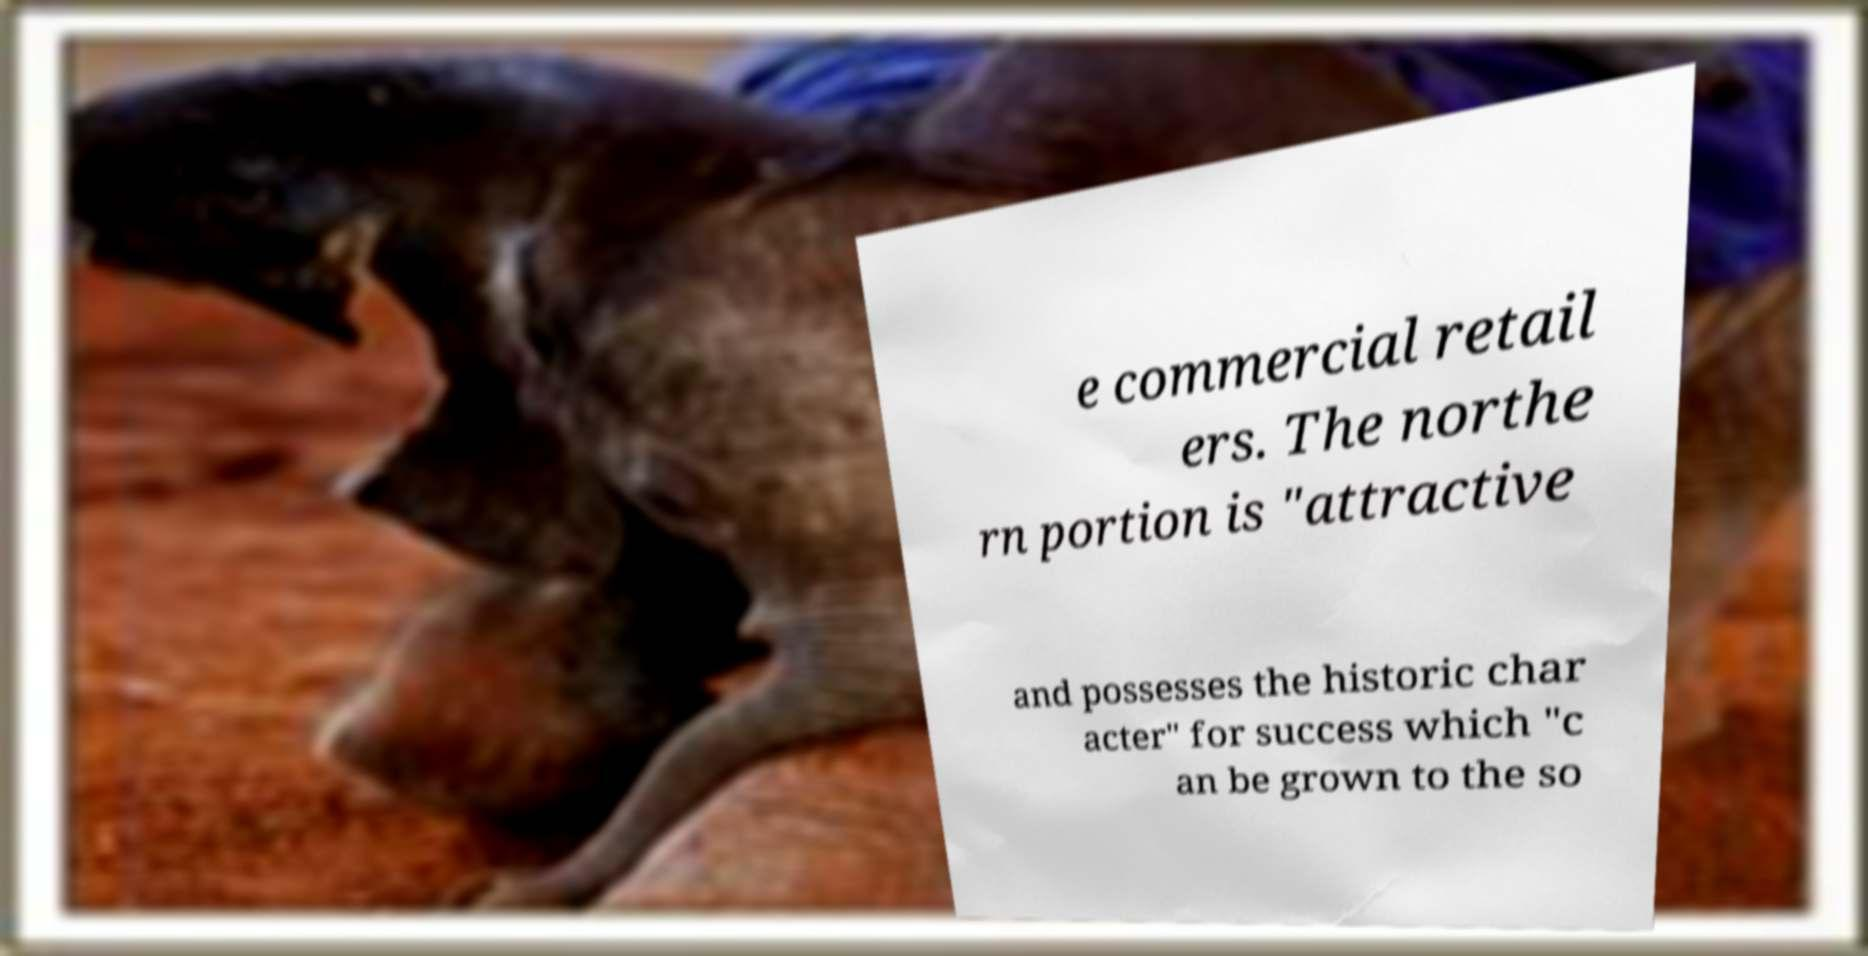Please identify and transcribe the text found in this image. e commercial retail ers. The northe rn portion is "attractive and possesses the historic char acter" for success which "c an be grown to the so 